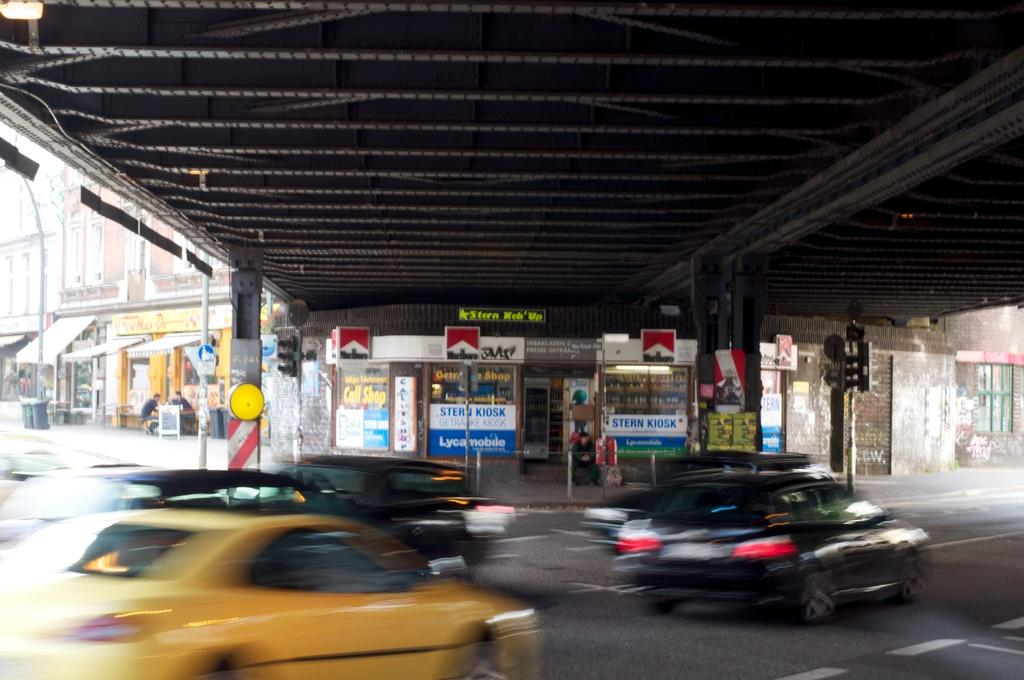<image>
Relay a brief, clear account of the picture shown. Traffic is going down a street that goes under an overpass and there are two signs for Lycan Mobile. 